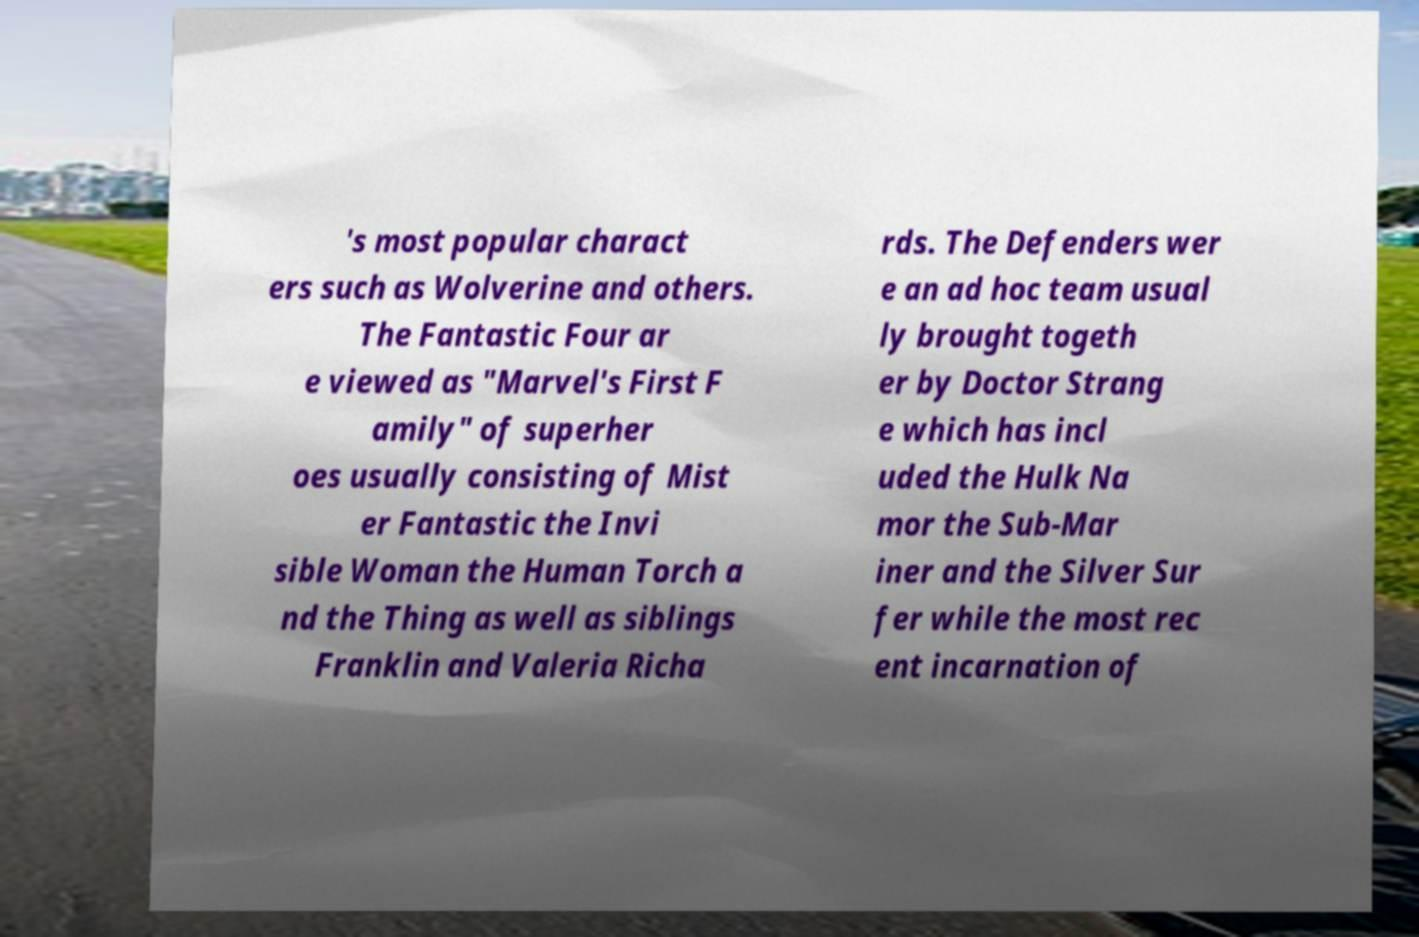I need the written content from this picture converted into text. Can you do that? 's most popular charact ers such as Wolverine and others. The Fantastic Four ar e viewed as "Marvel's First F amily" of superher oes usually consisting of Mist er Fantastic the Invi sible Woman the Human Torch a nd the Thing as well as siblings Franklin and Valeria Richa rds. The Defenders wer e an ad hoc team usual ly brought togeth er by Doctor Strang e which has incl uded the Hulk Na mor the Sub-Mar iner and the Silver Sur fer while the most rec ent incarnation of 